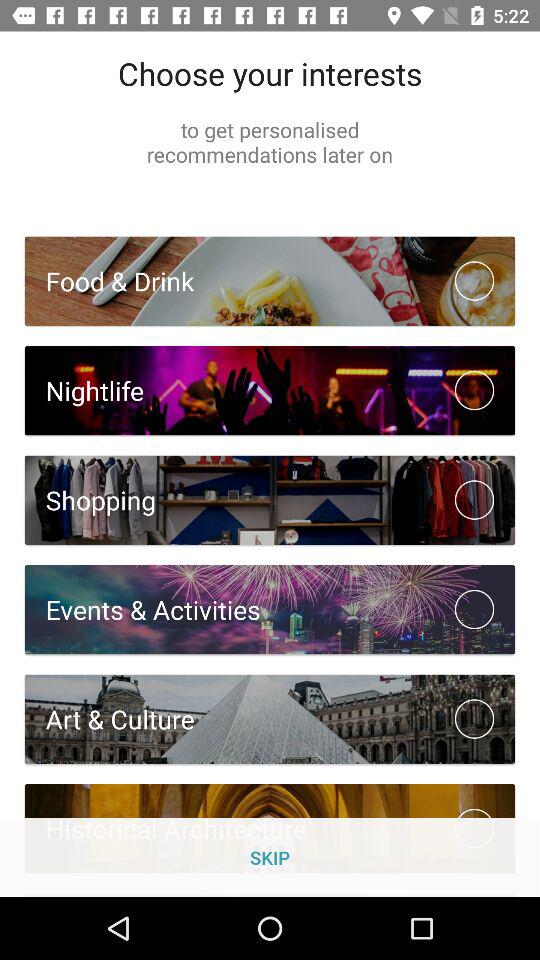How many interest categories are there in total?
Answer the question using a single word or phrase. 6 